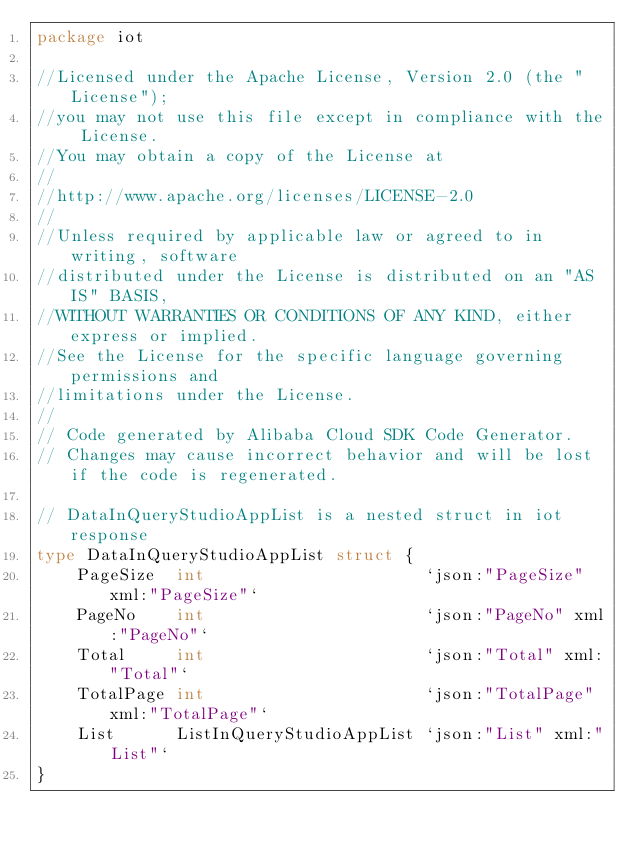Convert code to text. <code><loc_0><loc_0><loc_500><loc_500><_Go_>package iot

//Licensed under the Apache License, Version 2.0 (the "License");
//you may not use this file except in compliance with the License.
//You may obtain a copy of the License at
//
//http://www.apache.org/licenses/LICENSE-2.0
//
//Unless required by applicable law or agreed to in writing, software
//distributed under the License is distributed on an "AS IS" BASIS,
//WITHOUT WARRANTIES OR CONDITIONS OF ANY KIND, either express or implied.
//See the License for the specific language governing permissions and
//limitations under the License.
//
// Code generated by Alibaba Cloud SDK Code Generator.
// Changes may cause incorrect behavior and will be lost if the code is regenerated.

// DataInQueryStudioAppList is a nested struct in iot response
type DataInQueryStudioAppList struct {
	PageSize  int                      `json:"PageSize" xml:"PageSize"`
	PageNo    int                      `json:"PageNo" xml:"PageNo"`
	Total     int                      `json:"Total" xml:"Total"`
	TotalPage int                      `json:"TotalPage" xml:"TotalPage"`
	List      ListInQueryStudioAppList `json:"List" xml:"List"`
}
</code> 